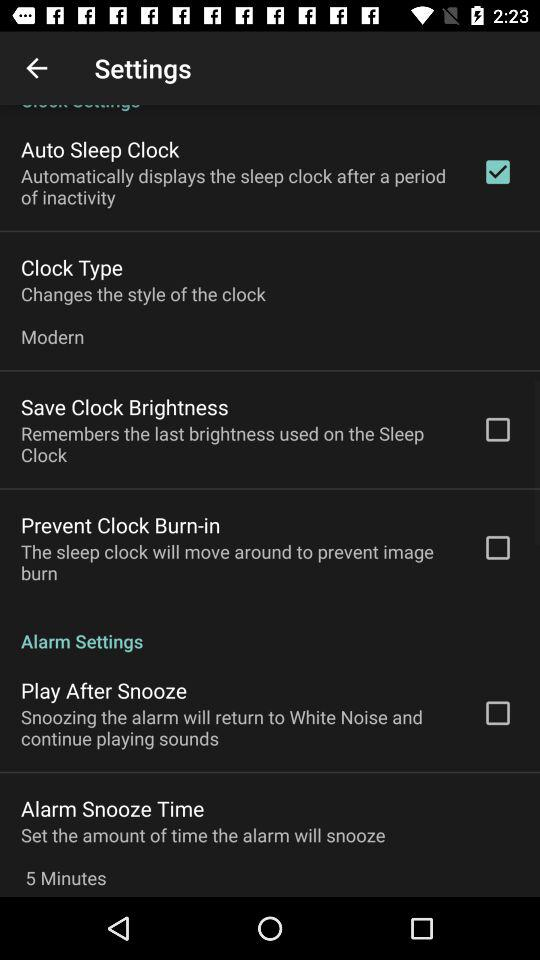What is the setting for clock type? The setting for clock type is "Modern". 